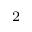Convert formula to latex. <formula><loc_0><loc_0><loc_500><loc_500>_ { 2 }</formula> 